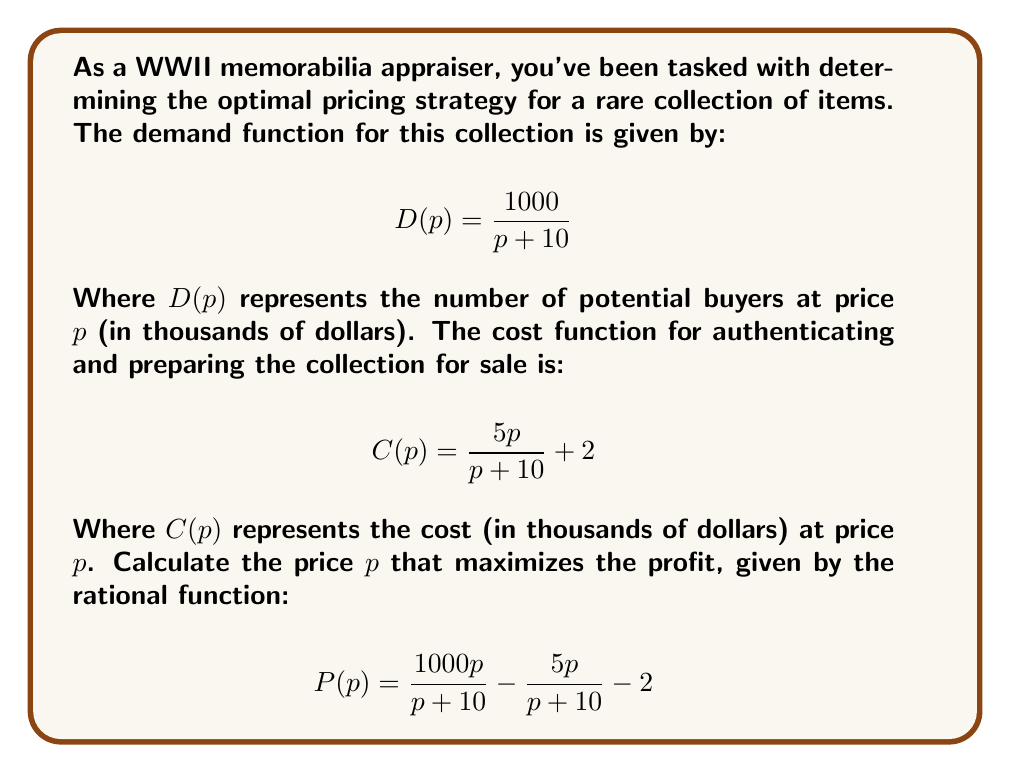Solve this math problem. Let's approach this step-by-step:

1) The profit function $P(p)$ is given by revenue minus cost:
   $$P(p) = pD(p) - C(p)$$

2) Substituting the given functions:
   $$P(p) = p \cdot \frac{1000}{p + 10} - \left(\frac{5p}{p + 10} + 2\right)$$

3) Simplifying:
   $$P(p) = \frac{1000p}{p + 10} - \frac{5p}{p + 10} - 2$$

4) To find the maximum profit, we need to find where the derivative of $P(p)$ equals zero:
   $$\frac{d}{dp}P(p) = 0$$

5) Using the quotient rule to differentiate:
   $$\frac{d}{dp}P(p) = \frac{1000(p+10) - 1000p}{(p+10)^2} - \frac{5(p+10) - 5p}{(p+10)^2}$$

6) Simplifying:
   $$\frac{d}{dp}P(p) = \frac{10000 - 5p - 50}{(p+10)^2} = \frac{9950 - 5p}{(p+10)^2}$$

7) Setting this equal to zero:
   $$\frac{9950 - 5p}{(p+10)^2} = 0$$

8) The numerator must equal zero (the denominator can't be zero as $p$ is non-negative):
   $$9950 - 5p = 0$$

9) Solving for $p$:
   $$5p = 9950$$
   $$p = 1990$$

10) To confirm this is a maximum, we could check the second derivative is negative at this point (omitted for brevity).

Therefore, the optimal price is $1,990,000.
Answer: $1,990,000 